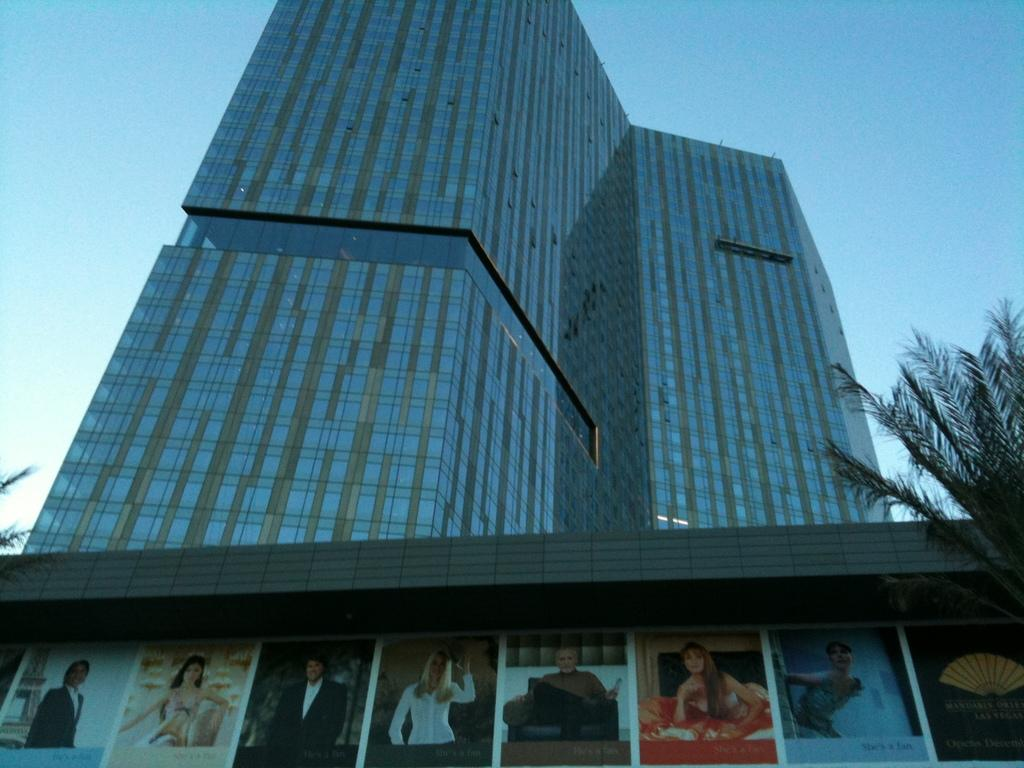What is in the foreground of the image? There are banners with photos and text in the foreground. What can be seen in the background of the image? There is a building and a group of plants in the background. What is visible in the sky in the image? The sky is visible in the background of the image. What type of calculator can be seen in the image? There is no calculator present in the image. What body part is visible in the image? There are no body parts visible in the image; it features banners, a building, plants, and the sky. 